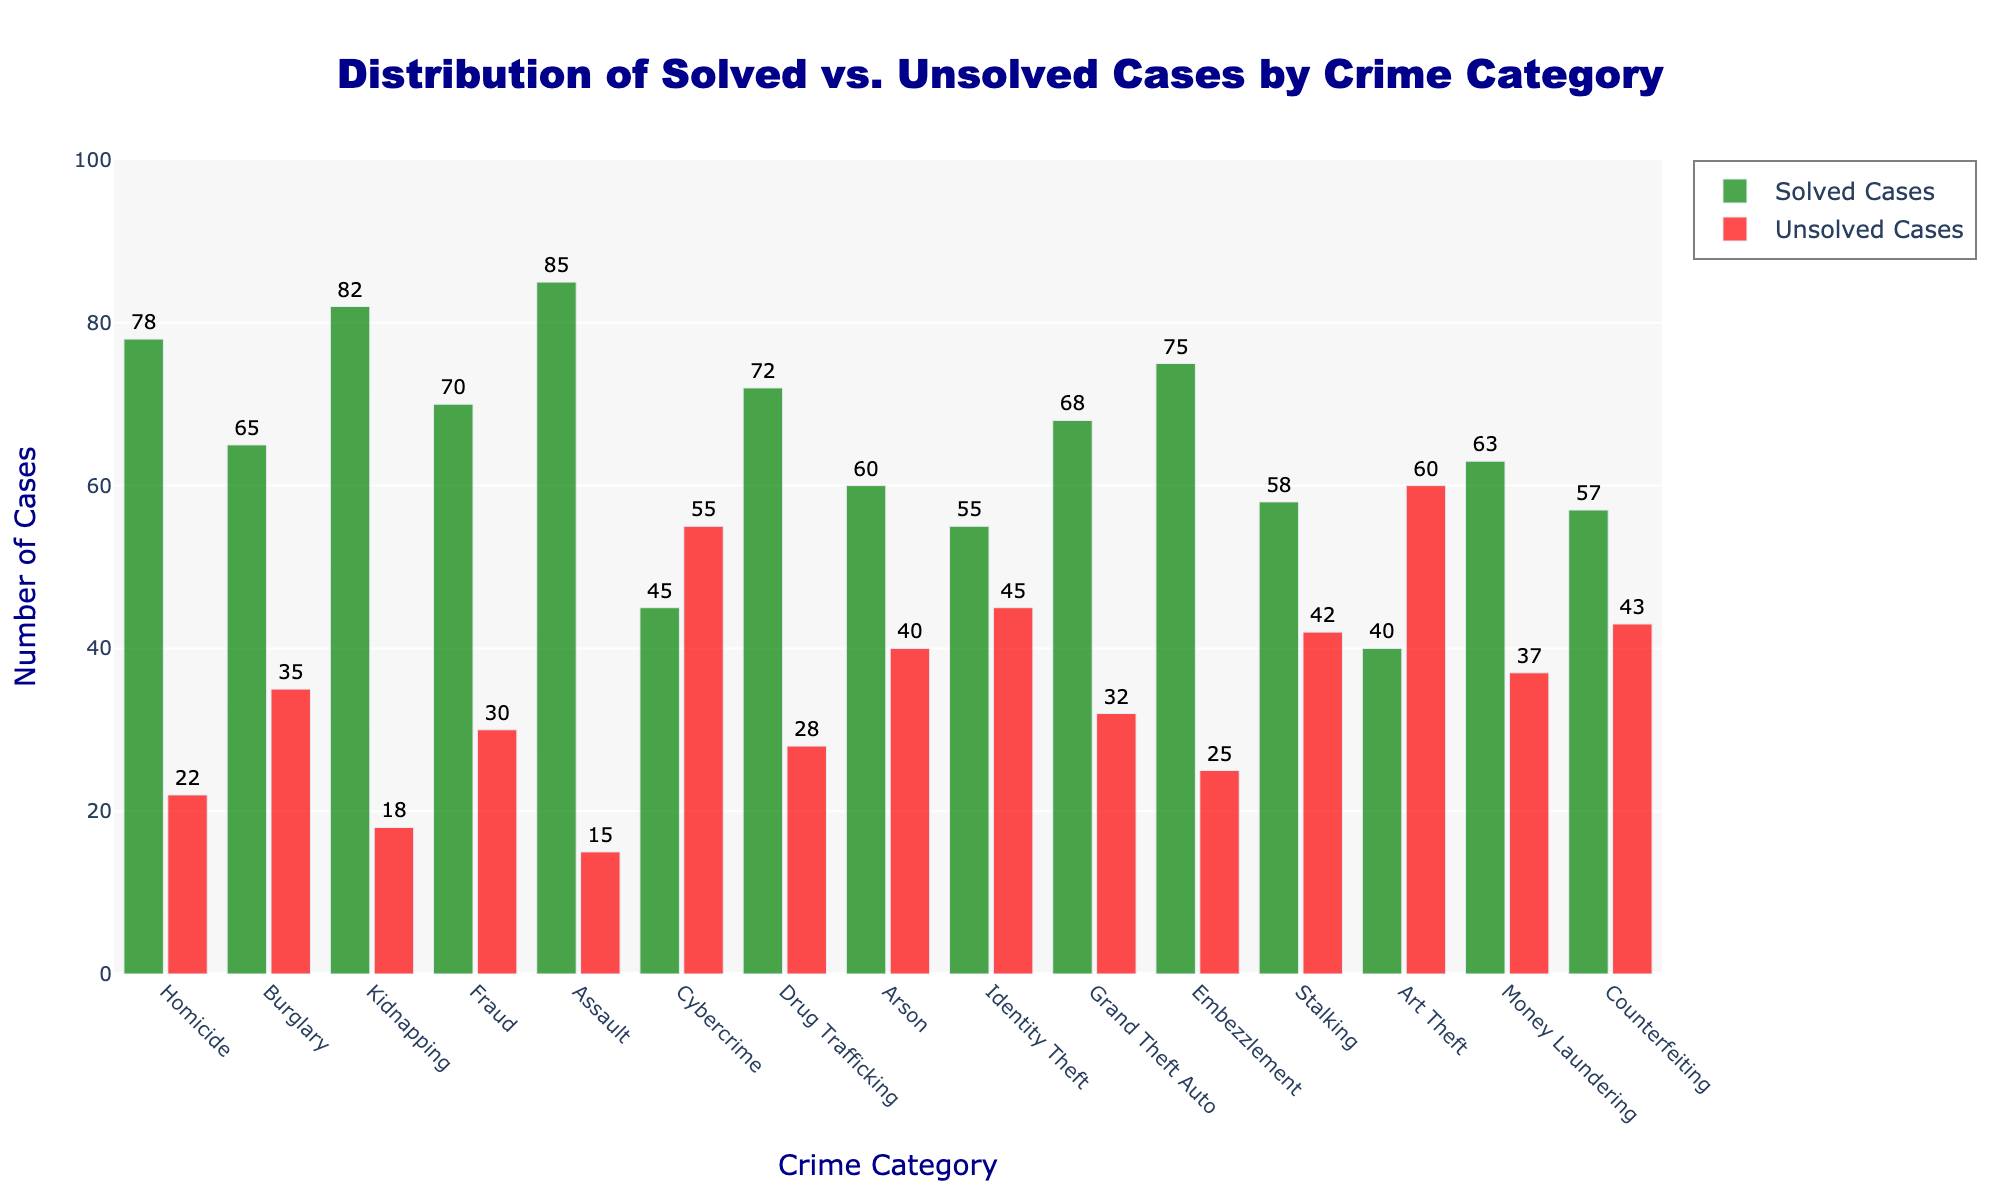What crime category has the highest number of solved cases? Find the highest bar among the "Solved Cases" in green and read the category on the x-axis.
Answer: Assault How many total cases are there for Cybercrime? Sum the solved and unsolved cases for Cybercrime (45 solved + 55 unsolved).
Answer: 100 Which crime category has more unsolved than solved cases? Identify the categories where the red bar (unsolved cases) is taller than the green bar (solved cases).
Answer: Cybercrime, Art Theft What's the difference between solved and unsolved cases for Burglary? Subtract the number of unsolved cases from solved cases for Burglary (65 solved - 35 unsolved).
Answer: 30 Which crime category has the least number of solved cases? Find the shortest bar among the "Solved Cases" in green and read the category on the x-axis.
Answer: Art Theft Is the number of solved cases for Fraud greater than the number of solved cases for Grand Theft Auto? Compare the height of the green bars for Fraud and Grand Theft Auto.
Answer: Yes What is the total number of cases for Homicide and Kidnapping combined? Add both solved and unsolved cases for Homicide and Kidnapping (78 + 22 for Homicide, 82 + 18 for Kidnapping).
Answer: 200 Which has more unsolved cases: Drug Trafficking or Identity Theft? Compare the height of the red bars for Drug Trafficking and Identity Theft.
Answer: Identity Theft What is the ratio of solved to unsolved cases for Arson? Divide the number of solved cases by the number of unsolved cases for Arson (60 solved / 40 unsolved).
Answer: 1.5 Is the combined number of solved cases for Counterfeiting and Embezzlement greater than the number of solved cases for Assault? Sum the solved cases for Counterfeiting and Embezzlement and compare with Assault (57 for Counterfeiting + 75 for Embezzlement > 85 for Assault).
Answer: No 